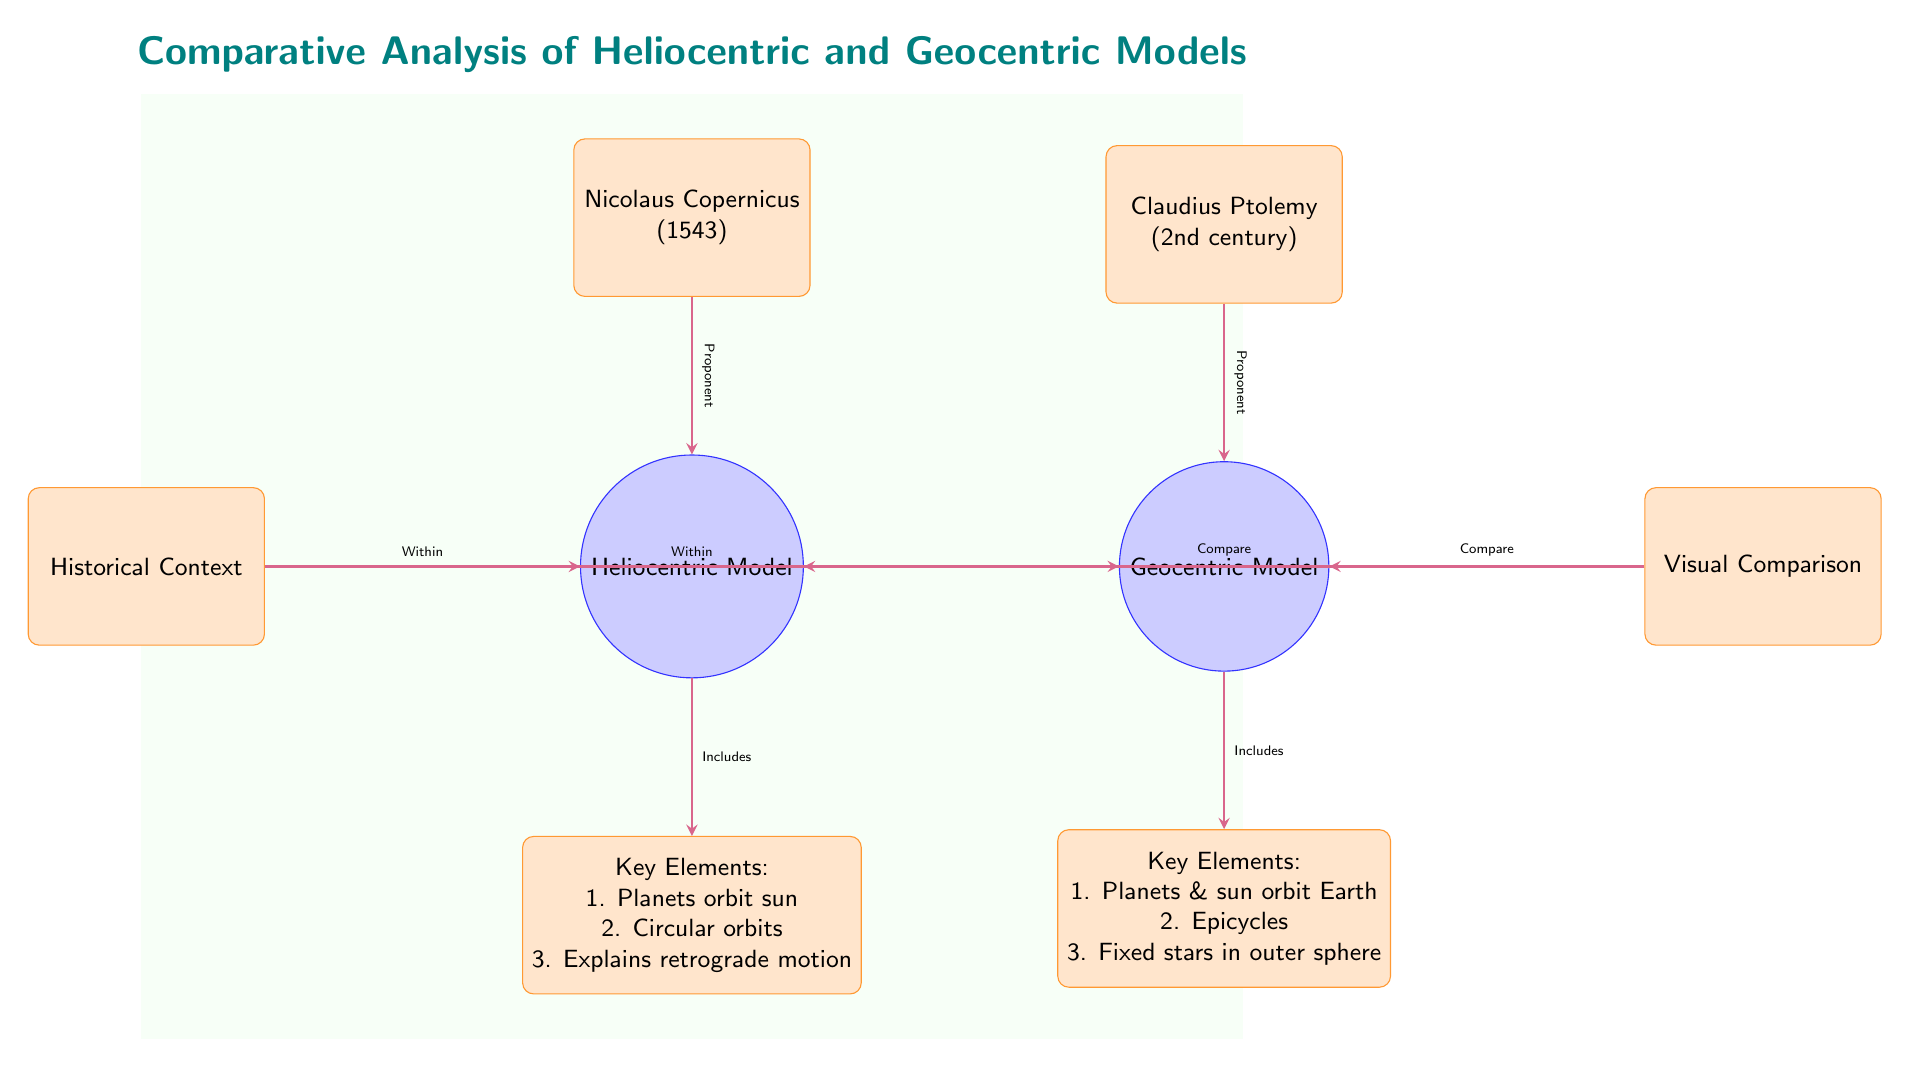What are the two models compared in the diagram? The diagram explicitly shows two circular nodes: one labeled "Heliocentric Model" and the other "Geocentric Model." There are no other model names provided, making the identification straightforward.
Answer: Heliocentric Model, Geocentric Model Who is the proponent of the Geocentric Model? The diagram has a box labeled "Claudius Ptolemy" located above the Geocentric Model circle, with an arrow indicating he is the proponent of this model.
Answer: Claudius Ptolemy What do the key elements of the Heliocentric Model include? The diagram presents a box below the Heliocentric Model labeled "Key Elements," which lists three essential features: 1. Planets orbit sun, 2. Circular orbits, 3. Explains retrograde motion.
Answer: 1. Planets orbit sun, 2. Circular orbits, 3. Explains retrograde motion How do the models explain planetary motion differently? By analyzing the arrows leading to the key elements, the Heliocentric Model states that "Planets orbit sun," while the Geocentric Model states "Planets & sun orbit Earth" with a reference to "Epicycles." This contrast illustrates their differing approaches.
Answer: Heliocentric: Planets orbit sun; Geocentric: Planets & sun orbit Earth What historical context applies to both models in the diagram? The diagram includes a box labeled "Historical Context" that is positioned to the left of both model circles, connected by arrows; hence, this context applies to both the Heliocentric and Geocentric Models.
Answer: Within both models What comparison is made visually in the diagram? There is a box labeled "Visual Comparison" on the right of the Geocentric Model that connects to both models, indicating that the diagram facilitates a visual comparison between the two models.
Answer: Compare How many key elements are listed for each model? The Heliocentric Model has three key elements listed, while the Geocentric Model also presents three key elements; both have their individual boxes below each model.
Answer: 3 for each model What century did Nicolaus Copernicus propose the Heliocentric Model? The box labeled "Nicolaus Copernicus" states "(1543)", indicating the year he proposed the model, thus indirectly suggesting it is within the 16th century.
Answer: 1543 What are the differences in the celestial bodies' orbits according to both models? The Heliocentric Model asserts that "Planets orbit sun" while the Geocentric Model includes "Epicycles" to explain the motion of planets that orbit Earth, which are contrasted visually.
Answer: Heliocentric: Planets orbit sun; Geocentric: Epicycles 